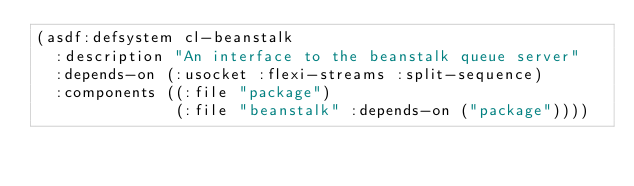<code> <loc_0><loc_0><loc_500><loc_500><_Lisp_>(asdf:defsystem cl-beanstalk
  :description "An interface to the beanstalk queue server"
  :depends-on (:usocket :flexi-streams :split-sequence)
  :components ((:file "package")
               (:file "beanstalk" :depends-on ("package"))))
</code> 